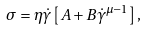<formula> <loc_0><loc_0><loc_500><loc_500>\sigma = \eta \dot { \gamma } \left [ A + B \dot { \gamma } ^ { \mu - 1 } \right ] ,</formula> 